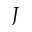Convert formula to latex. <formula><loc_0><loc_0><loc_500><loc_500>J</formula> 